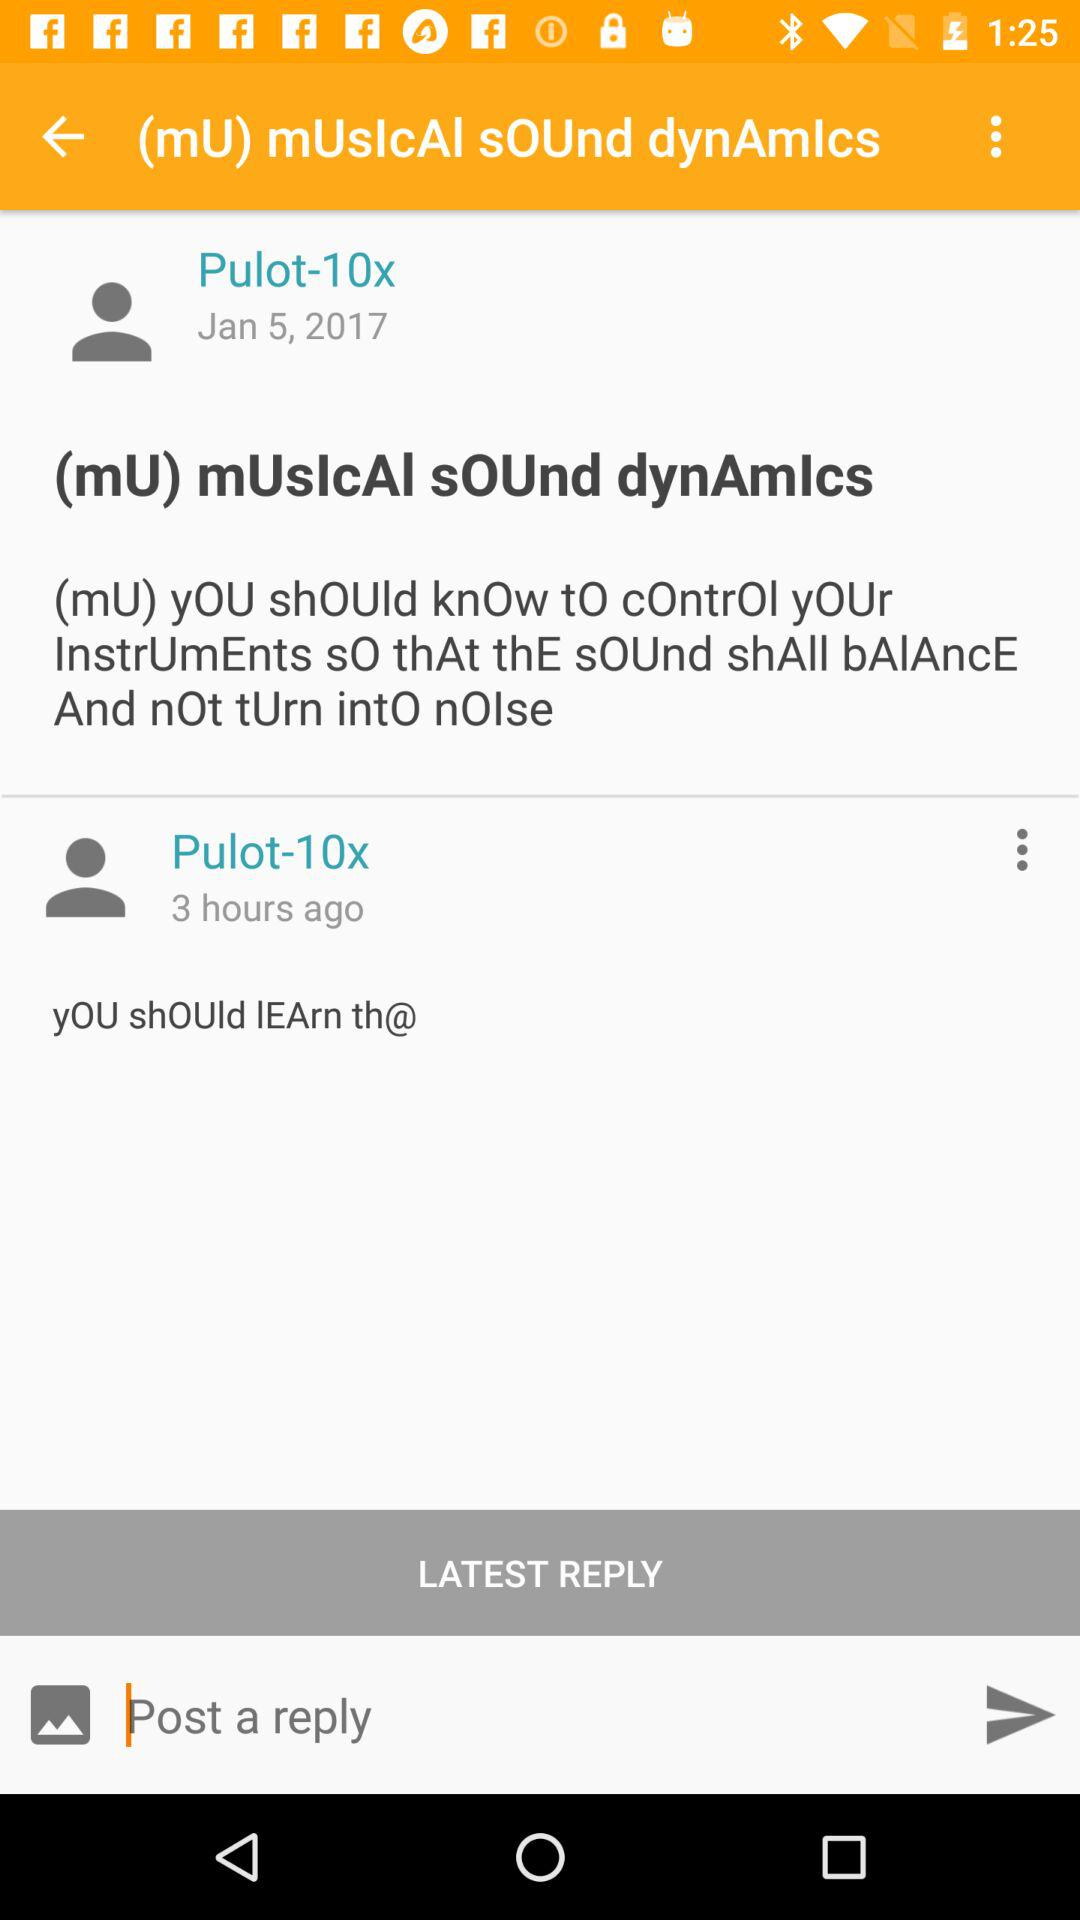When was the "Pulot-10x" updated? The "Pulot-10x" was updated 3 hours ago. 